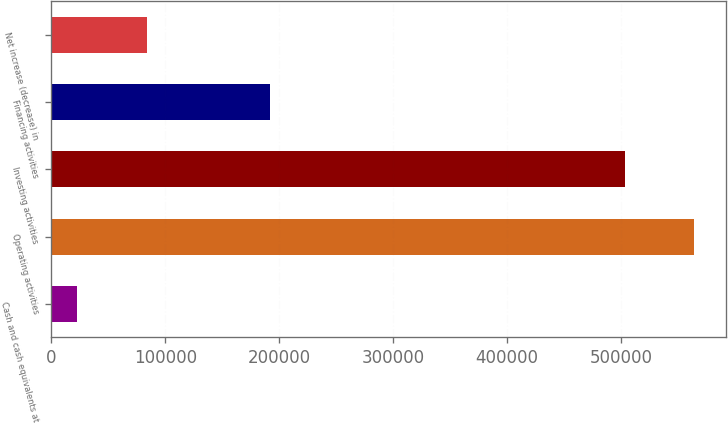Convert chart to OTSL. <chart><loc_0><loc_0><loc_500><loc_500><bar_chart><fcel>Cash and cash equivalents at<fcel>Operating activities<fcel>Investing activities<fcel>Financing activities<fcel>Net increase (decrease) in<nl><fcel>22599<fcel>564124<fcel>503524<fcel>191808<fcel>83503<nl></chart> 